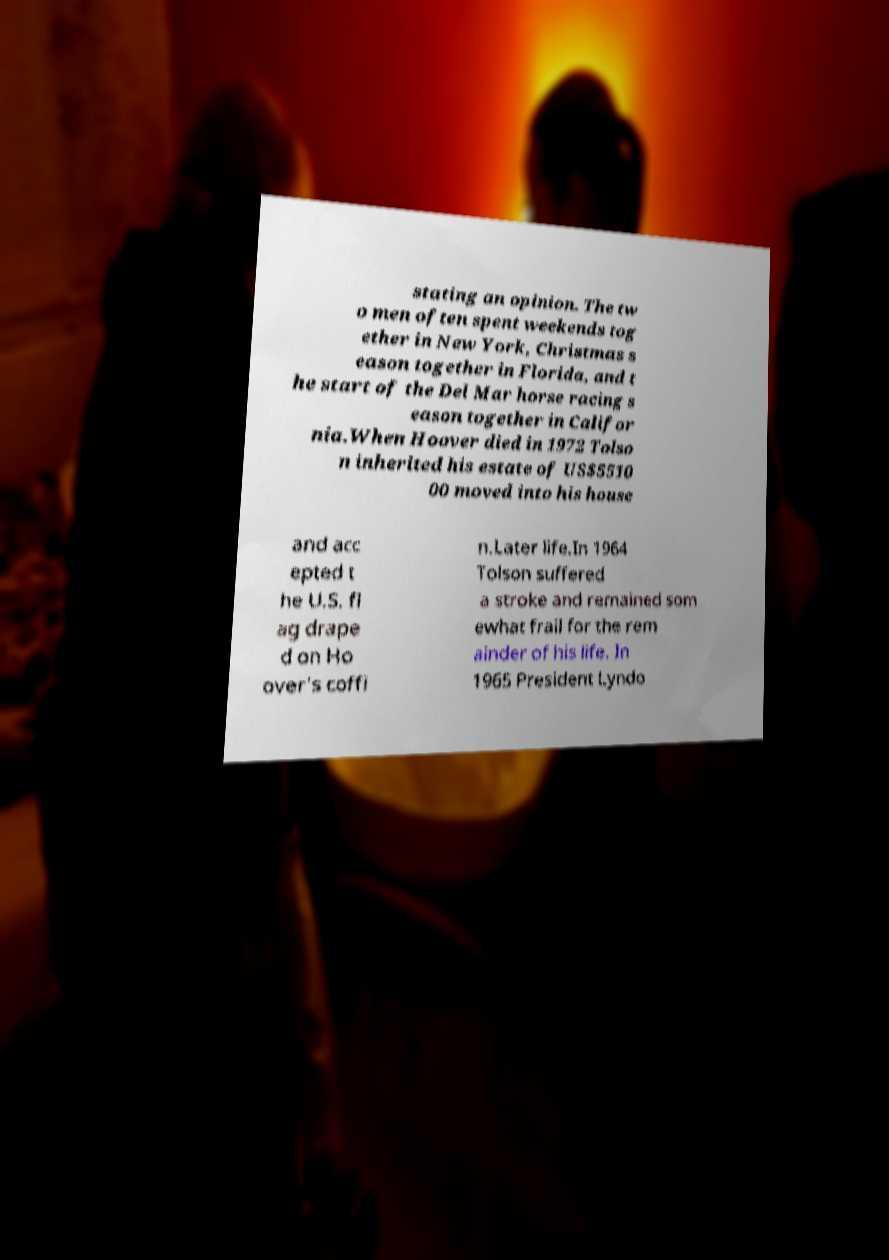What messages or text are displayed in this image? I need them in a readable, typed format. stating an opinion. The tw o men often spent weekends tog ether in New York, Christmas s eason together in Florida, and t he start of the Del Mar horse racing s eason together in Califor nia.When Hoover died in 1972 Tolso n inherited his estate of US$5510 00 moved into his house and acc epted t he U.S. fl ag drape d on Ho over's coffi n.Later life.In 1964 Tolson suffered a stroke and remained som ewhat frail for the rem ainder of his life. In 1965 President Lyndo 